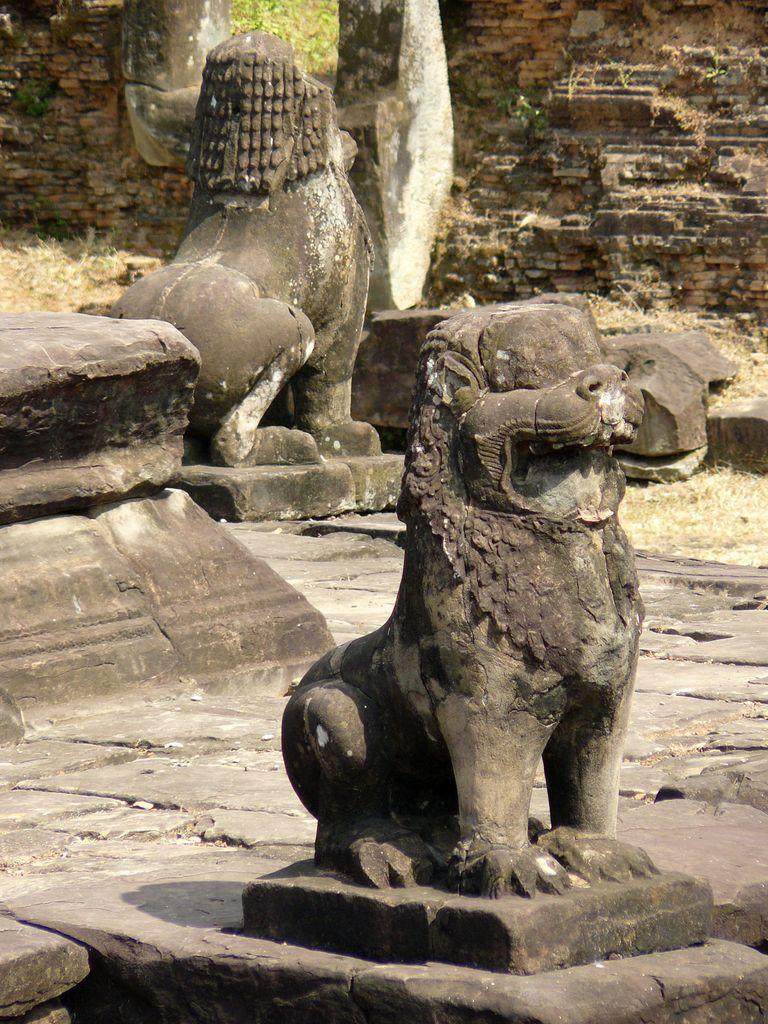What type of natural elements can be seen in the image? There are stones in the image. What man-made objects are present in the image? There are statues in the image. What type of structure is visible in the image? There is a wall in the image. What can be seen in the background of the image? There are leaves visible in the background of the image. How many eggs are visible in the image? There are no eggs present in the image. What type of fruit is being used to say good-bye in the image? There is no fruit or action of saying good-bye present in the image. How many cherries are visible on the wall in the image? There are no cherries visible on the wall in the image. 